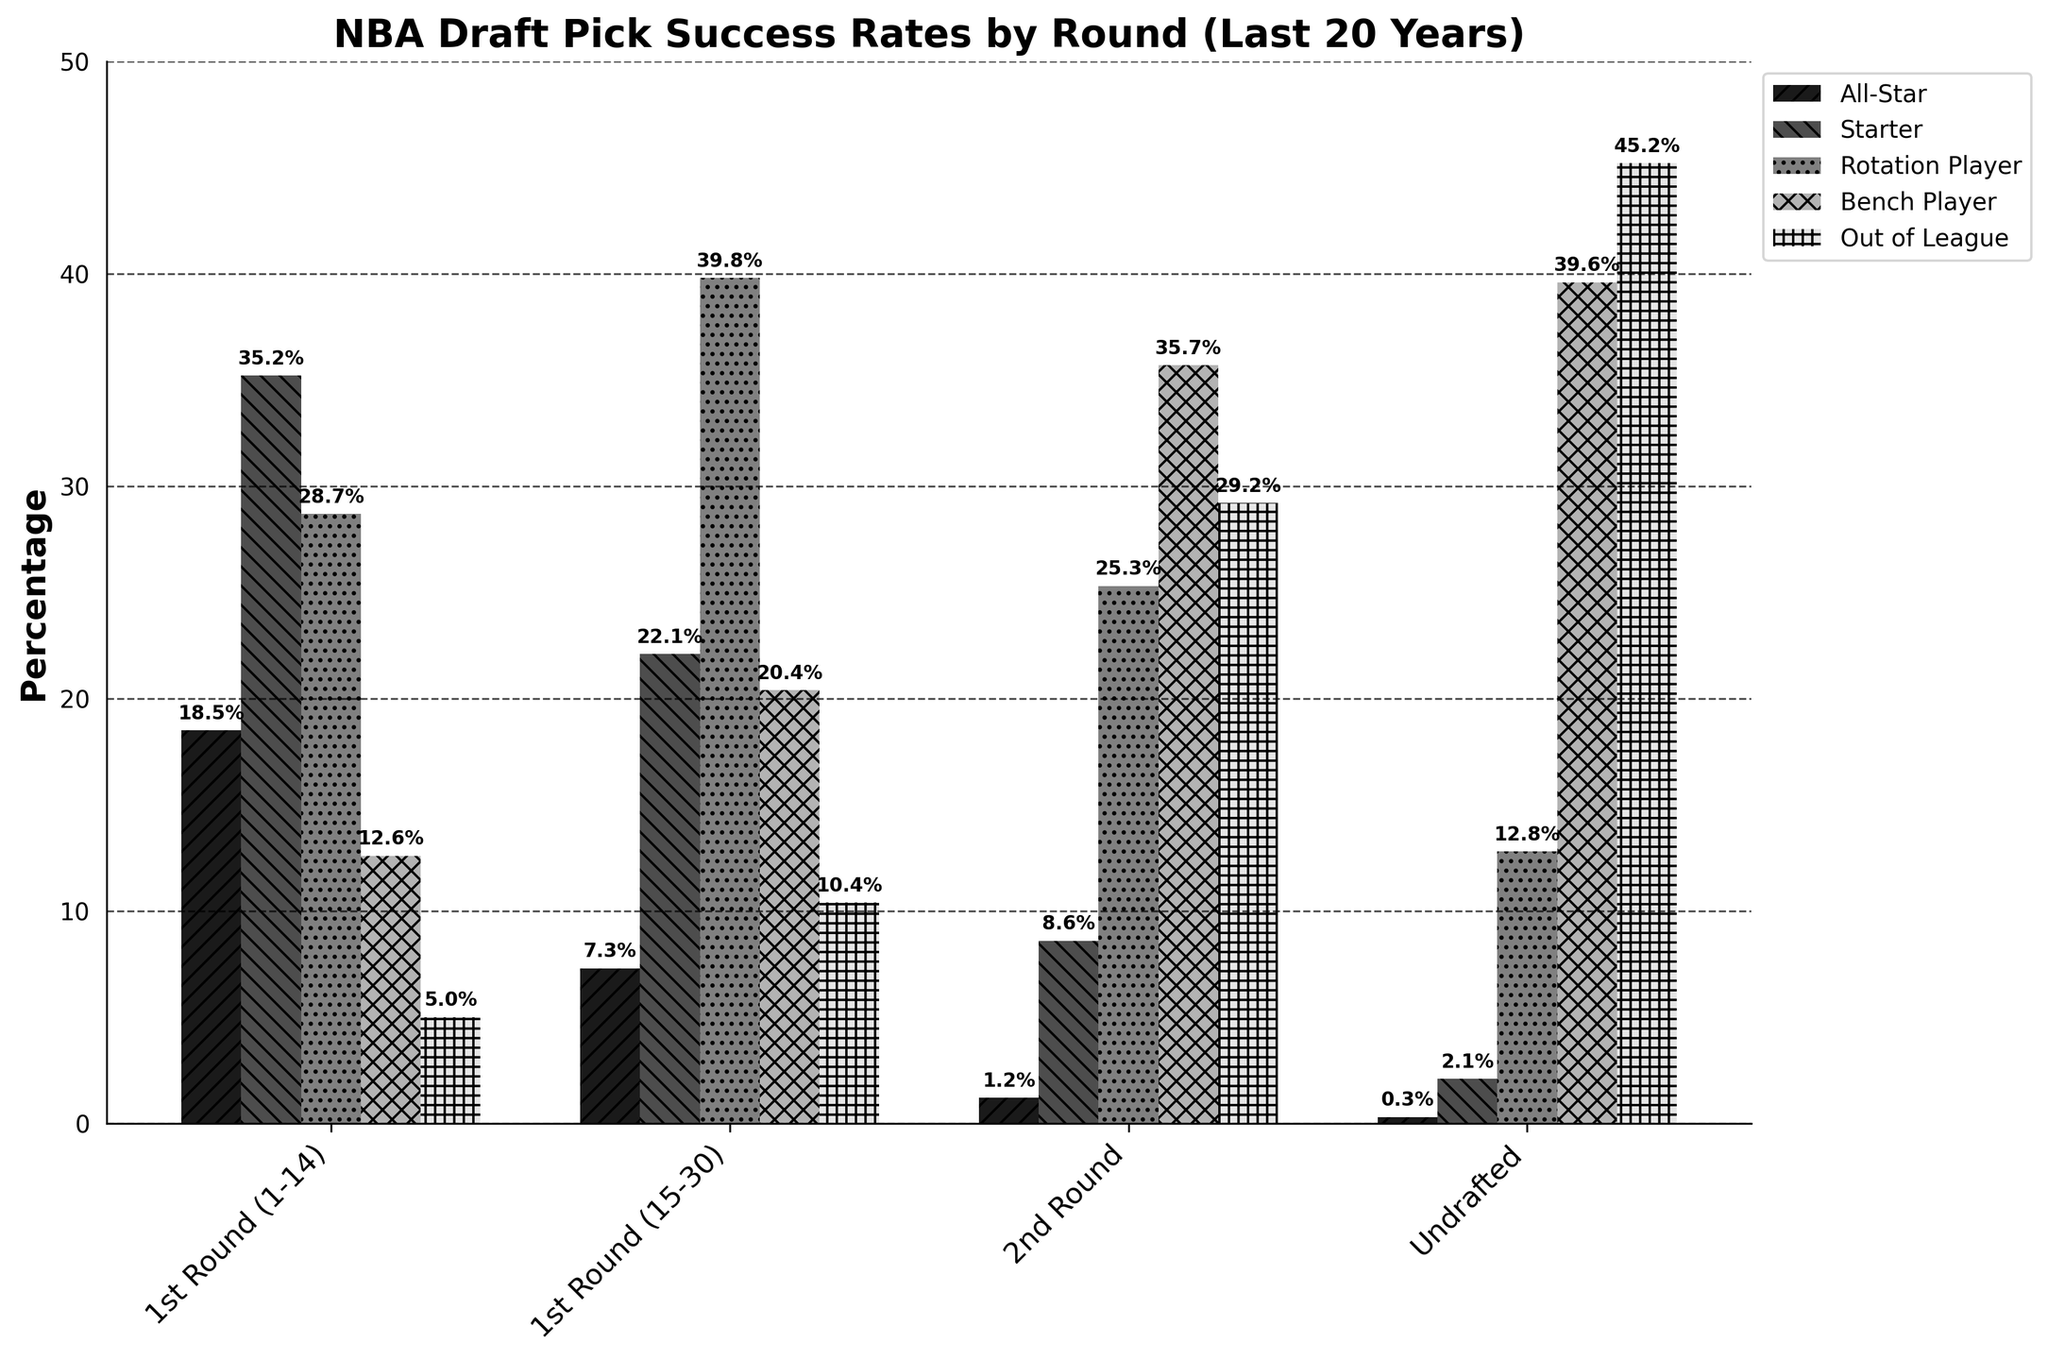What round has the highest percentage of All-Star players? To find the round with the highest percentage of All-Star players, look at the bar labeled "All-Star %". The tallest bar in this section is in the "1st Round (1-14)", indicating this round has the highest percentage of All-Star players.
Answer: 1st Round (1-14) What's the percentage difference between Bench Players in the 2nd Round and Bench Players among Undrafted? To find the percentage difference between Bench Players in the 2nd Round and among Undrafted, subtract the percentage of Bench Players in the 2nd Round (35.7%) from the percentage of Bench Players among Undrafted (39.6%). So, the calculation is 39.6% - 35.7% = 3.9%.
Answer: 3.9% Which category has the lowest percentage of All-Star players? To determine the category with the lowest percentage of All-Star players, look at the "All-Star %" bars and identify the shortest one. The bar in the "Undrafted" category is the shortest in this section.
Answer: Undrafted How does the percentage of Out of League players in the 2nd Round compare to the 1st Round (15-30)? Compare the heights of the bars labeled "Out of League %" for the 2nd Round and 1st Round (15-30). The 2nd Round percentage (29.2%) is higher than the 1st Round (15-30) percentage (10.4%).
Answer: Higher What is the combined percentage of Starters and Rotation Players in the 1st Round (1-14)? Add the percentage of Starters (35.2%) and Rotation Players (28.7%) in the 1st Round (1-14). The sum is 35.2% + 28.7% = 63.9%.
Answer: 63.9% Which round has a higher percentage of Bench Players, the 2nd Round or the 1st Round (15-30)? Compare the heights of the bars labeled "Bench Player %" for the 2nd Round and 1st Round (15-30). The bar for the 2nd Round (35.7%) is higher than that for the 1st Round (15-30) (20.4%).
Answer: 2nd Round What is the difference between the percentage of All-Star players in the 1st Round and Undrafted? Subtract the percentage of All-Star players in the Undrafted category (0.3%) from the percentage in the 1st Round (1-14) (18.5%). The calculation is 18.5% - 0.3% = 18.2%.
Answer: 18.2% Is the percentage of Out of League players higher in the 2nd Round or among Undrafted? Compare the heights of the "Out of League %" bars for the 2nd Round (29.2%) and Undrafted (45.2%). The percentage is higher among Undrafted.
Answer: Undrafted Which visual attribute helps to distinguish between the categories in the legend? The different categories in the legend are distinguished by unique patterns and shades of gray used in the bars, such as stripes, slashes, dots, and crosses.
Answer: Patterns and shades 